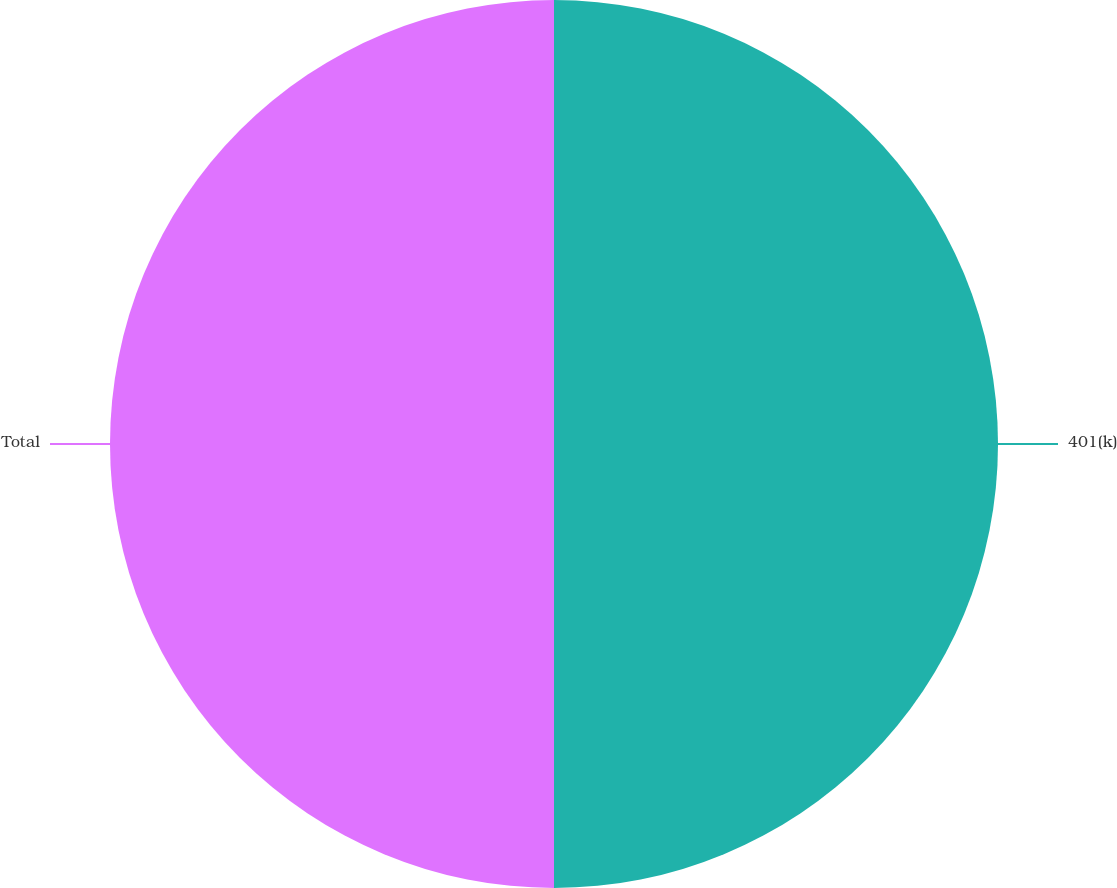<chart> <loc_0><loc_0><loc_500><loc_500><pie_chart><fcel>401(k)<fcel>Total<nl><fcel>50.0%<fcel>50.0%<nl></chart> 